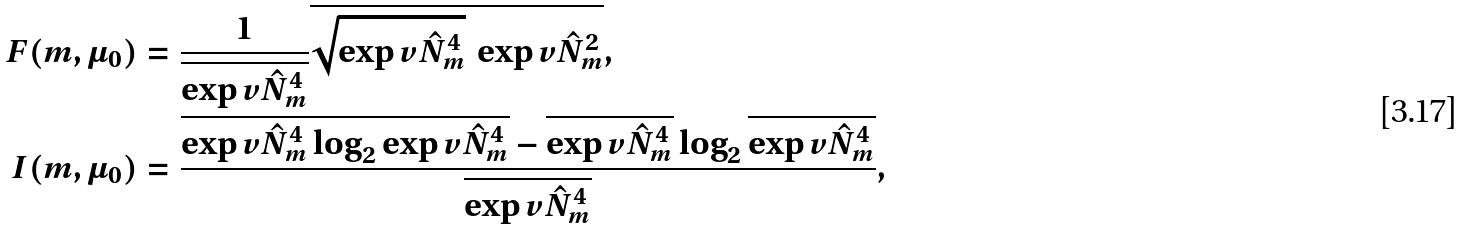<formula> <loc_0><loc_0><loc_500><loc_500>F ( m , \mu _ { 0 } ) & = \frac { 1 } { \overline { \exp v { \hat { N } _ { m } ^ { 4 } } } } \overline { \sqrt { \exp v { \hat { N } _ { m } ^ { 4 } } } \, \exp v { \hat { N } _ { m } ^ { 2 } } } , \\ I ( m , \mu _ { 0 } ) & = \frac { \overline { \exp v { \hat { N } _ { m } ^ { 4 } } \log _ { 2 } \exp v { \hat { N } _ { m } ^ { 4 } } } - \overline { \exp v { \hat { N } _ { m } ^ { 4 } } } \log _ { 2 } \overline { \exp v { \hat { N } _ { m } ^ { 4 } } } } { \overline { \exp v { \hat { N } _ { m } ^ { 4 } } } } ,</formula> 